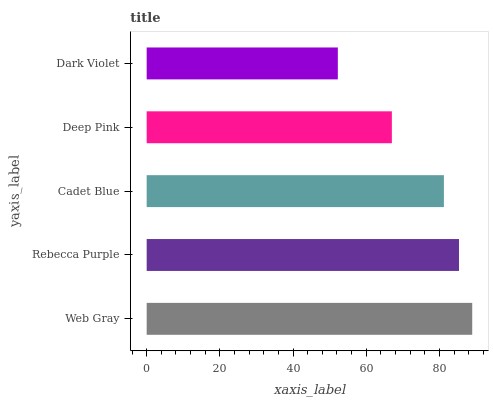Is Dark Violet the minimum?
Answer yes or no. Yes. Is Web Gray the maximum?
Answer yes or no. Yes. Is Rebecca Purple the minimum?
Answer yes or no. No. Is Rebecca Purple the maximum?
Answer yes or no. No. Is Web Gray greater than Rebecca Purple?
Answer yes or no. Yes. Is Rebecca Purple less than Web Gray?
Answer yes or no. Yes. Is Rebecca Purple greater than Web Gray?
Answer yes or no. No. Is Web Gray less than Rebecca Purple?
Answer yes or no. No. Is Cadet Blue the high median?
Answer yes or no. Yes. Is Cadet Blue the low median?
Answer yes or no. Yes. Is Dark Violet the high median?
Answer yes or no. No. Is Rebecca Purple the low median?
Answer yes or no. No. 